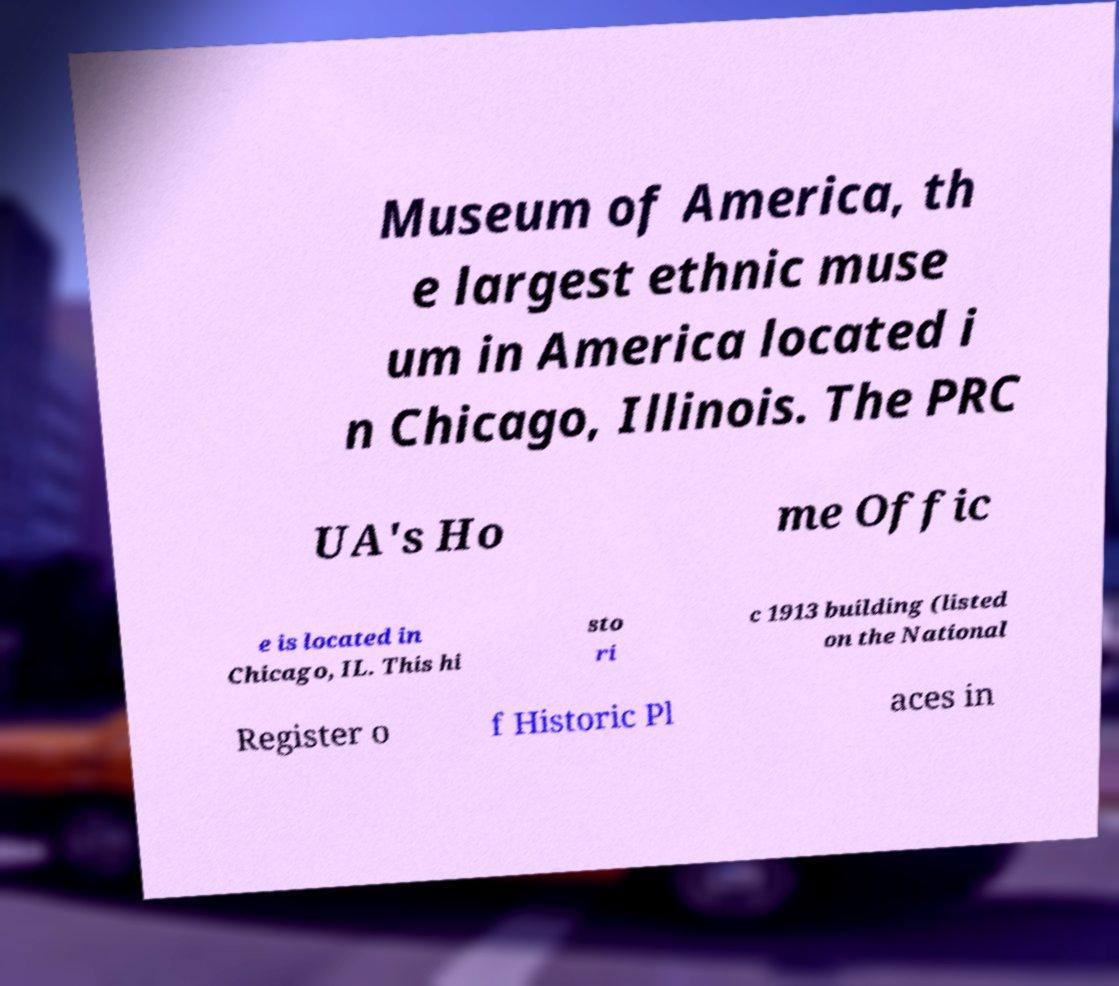Can you accurately transcribe the text from the provided image for me? Museum of America, th e largest ethnic muse um in America located i n Chicago, Illinois. The PRC UA's Ho me Offic e is located in Chicago, IL. This hi sto ri c 1913 building (listed on the National Register o f Historic Pl aces in 